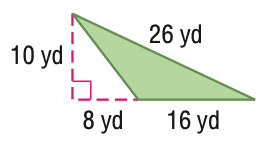Answer the mathemtical geometry problem and directly provide the correct option letter.
Question: Find the perimeter of the figure. Round to the nearest tenth if necessary.
Choices: A: 54.8 B: 60 C: 80 D: 109.6 A 